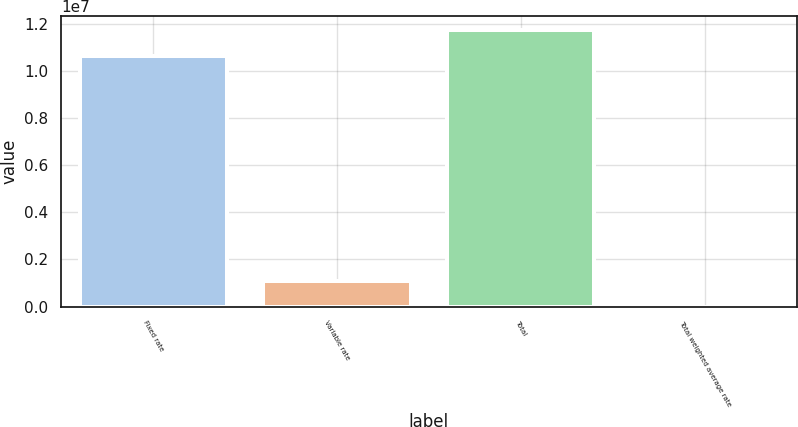Convert chart. <chart><loc_0><loc_0><loc_500><loc_500><bar_chart><fcel>Fixed rate<fcel>Variable rate<fcel>Total<fcel>Total weighted average rate<nl><fcel>1.06594e+07<fcel>1.10569e+06<fcel>1.17651e+07<fcel>4.57<nl></chart> 